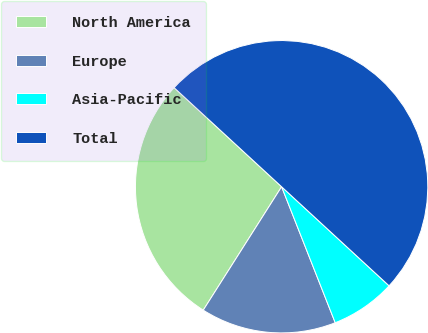Convert chart to OTSL. <chart><loc_0><loc_0><loc_500><loc_500><pie_chart><fcel>North America<fcel>Europe<fcel>Asia-Pacific<fcel>Total<nl><fcel>27.85%<fcel>14.98%<fcel>7.17%<fcel>50.0%<nl></chart> 